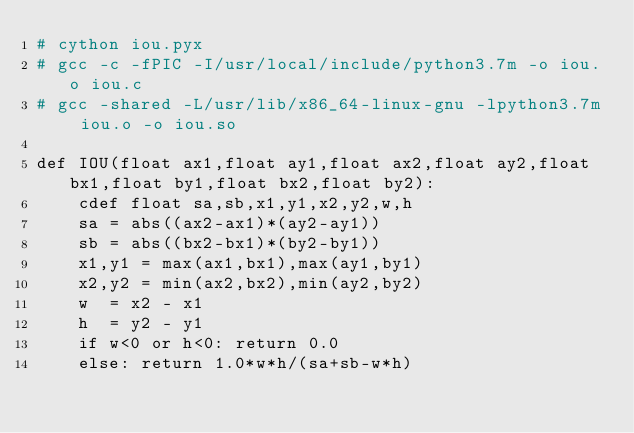Convert code to text. <code><loc_0><loc_0><loc_500><loc_500><_Cython_># cython iou.pyx
# gcc -c -fPIC -I/usr/local/include/python3.7m -o iou.o iou.c
# gcc -shared -L/usr/lib/x86_64-linux-gnu -lpython3.7m iou.o -o iou.so

def IOU(float ax1,float ay1,float ax2,float ay2,float bx1,float by1,float bx2,float by2):
    cdef float sa,sb,x1,y1,x2,y2,w,h
    sa = abs((ax2-ax1)*(ay2-ay1))
    sb = abs((bx2-bx1)*(by2-by1))
    x1,y1 = max(ax1,bx1),max(ay1,by1)
    x2,y2 = min(ax2,bx2),min(ay2,by2)
    w  = x2 - x1
    h  = y2 - y1
    if w<0 or h<0: return 0.0
    else: return 1.0*w*h/(sa+sb-w*h)</code> 